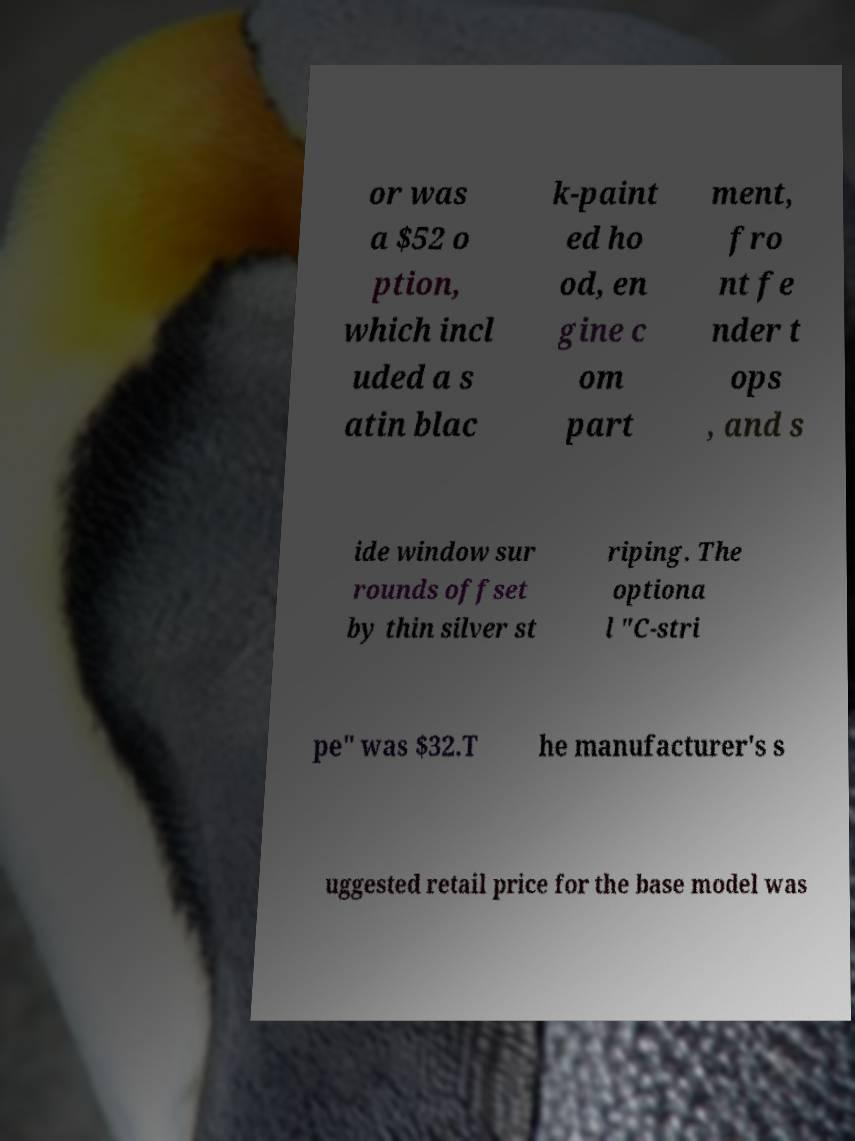I need the written content from this picture converted into text. Can you do that? or was a $52 o ption, which incl uded a s atin blac k-paint ed ho od, en gine c om part ment, fro nt fe nder t ops , and s ide window sur rounds offset by thin silver st riping. The optiona l "C-stri pe" was $32.T he manufacturer's s uggested retail price for the base model was 